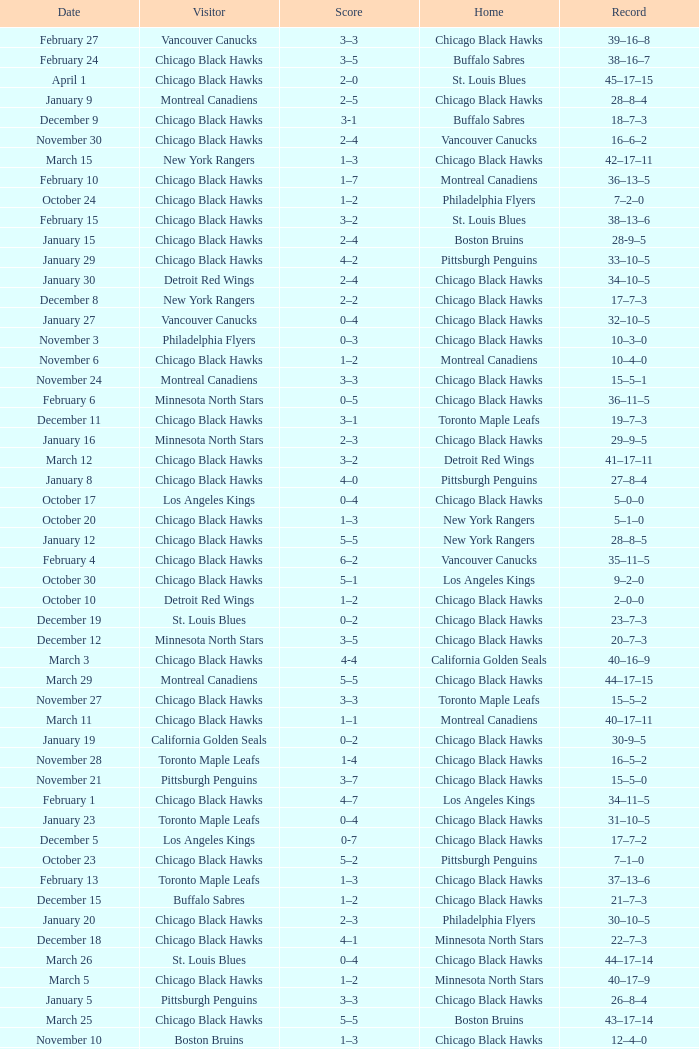What is the Score of the Chicago Black Hawks Home game with the Visiting Vancouver Canucks on November 17? 0-3. 